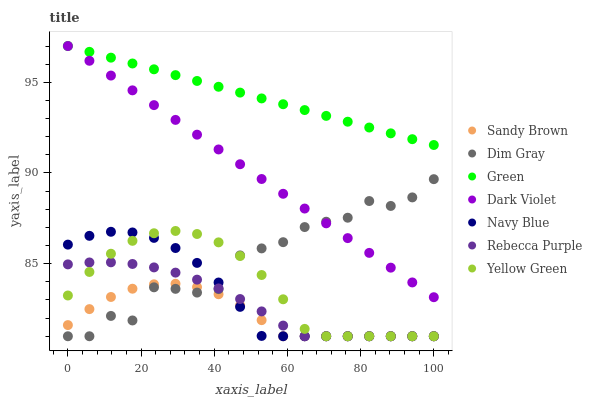Does Sandy Brown have the minimum area under the curve?
Answer yes or no. Yes. Does Green have the maximum area under the curve?
Answer yes or no. Yes. Does Yellow Green have the minimum area under the curve?
Answer yes or no. No. Does Yellow Green have the maximum area under the curve?
Answer yes or no. No. Is Dark Violet the smoothest?
Answer yes or no. Yes. Is Dim Gray the roughest?
Answer yes or no. Yes. Is Yellow Green the smoothest?
Answer yes or no. No. Is Yellow Green the roughest?
Answer yes or no. No. Does Dim Gray have the lowest value?
Answer yes or no. Yes. Does Dark Violet have the lowest value?
Answer yes or no. No. Does Green have the highest value?
Answer yes or no. Yes. Does Yellow Green have the highest value?
Answer yes or no. No. Is Yellow Green less than Green?
Answer yes or no. Yes. Is Green greater than Yellow Green?
Answer yes or no. Yes. Does Sandy Brown intersect Navy Blue?
Answer yes or no. Yes. Is Sandy Brown less than Navy Blue?
Answer yes or no. No. Is Sandy Brown greater than Navy Blue?
Answer yes or no. No. Does Yellow Green intersect Green?
Answer yes or no. No. 